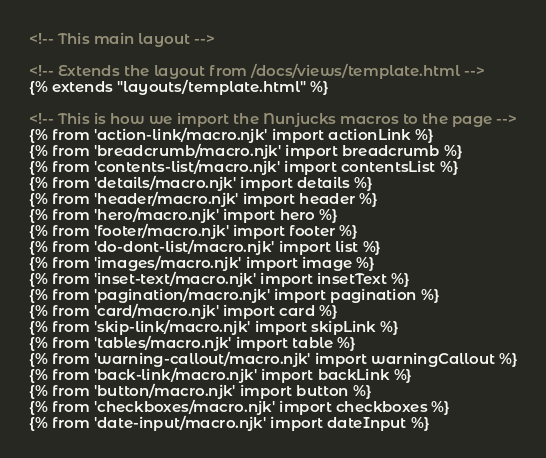<code> <loc_0><loc_0><loc_500><loc_500><_HTML_><!-- This main layout -->

<!-- Extends the layout from /docs/views/template.html -->
{% extends "layouts/template.html" %}

<!-- This is how we import the Nunjucks macros to the page -->
{% from 'action-link/macro.njk' import actionLink %}
{% from 'breadcrumb/macro.njk' import breadcrumb %}
{% from 'contents-list/macro.njk' import contentsList %}
{% from 'details/macro.njk' import details %}
{% from 'header/macro.njk' import header %}
{% from 'hero/macro.njk' import hero %}
{% from 'footer/macro.njk' import footer %}
{% from 'do-dont-list/macro.njk' import list %}
{% from 'images/macro.njk' import image %}
{% from 'inset-text/macro.njk' import insetText %}
{% from 'pagination/macro.njk' import pagination %}
{% from 'card/macro.njk' import card %}
{% from 'skip-link/macro.njk' import skipLink %}
{% from 'tables/macro.njk' import table %}
{% from 'warning-callout/macro.njk' import warningCallout %}
{% from 'back-link/macro.njk' import backLink %}
{% from 'button/macro.njk' import button %}
{% from 'checkboxes/macro.njk' import checkboxes %}
{% from 'date-input/macro.njk' import dateInput %}</code> 